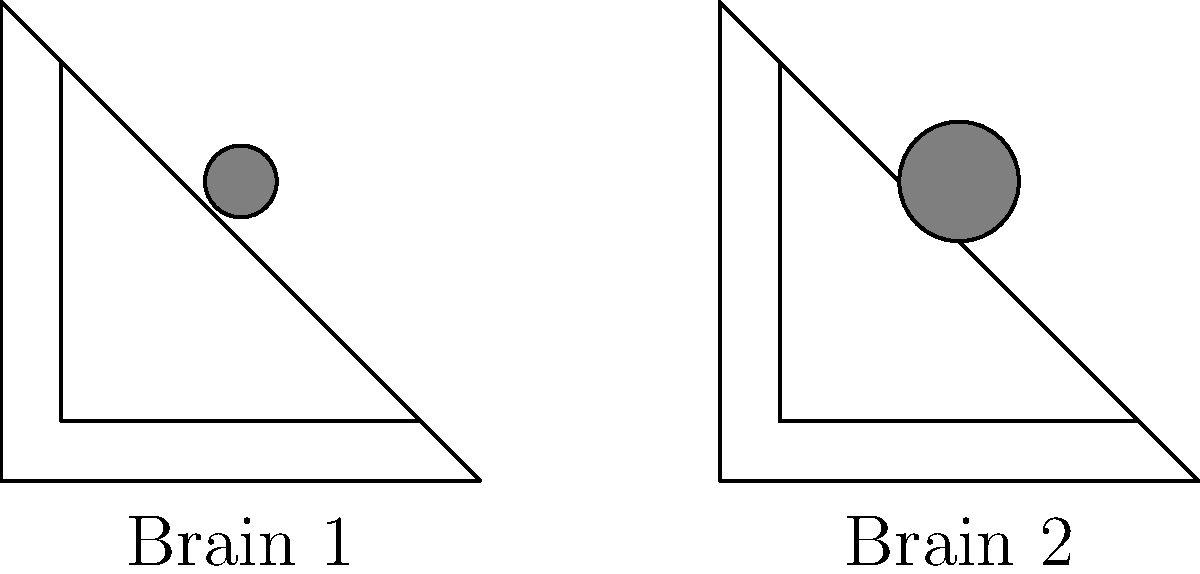Compare the two brain scan images above. Which structural difference is most apparent between Brain 1 and Brain 2? To analyze the structural differences between the two brain scans, let's follow these steps:

1. Overall shape: Both brains have a similar triangular shape, representing a simplified side view of the brain.

2. Internal structures: Both brains show an inner triangle, possibly representing the ventricles or white matter tracts.

3. Central structure: Both brains have a circular structure in the center, which could represent the thalamus or basal ganglia.

4. Size of central structure: This is where we see the most apparent difference.
   - In Brain 1, the central circular structure has a diameter of approximately 0.3 units.
   - In Brain 2, the central circular structure has a diameter of approximately 0.5 units.

5. Relative size: The central structure in Brain 2 is noticeably larger compared to the overall brain size than in Brain 1.

Therefore, the most apparent structural difference between Brain 1 and Brain 2 is the size of the central circular structure, which is larger in Brain 2.
Answer: Enlarged central structure in Brain 2 